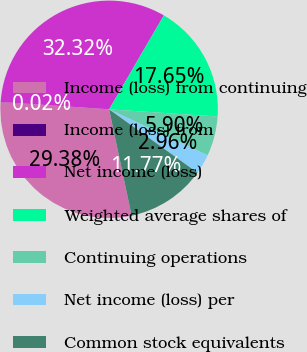<chart> <loc_0><loc_0><loc_500><loc_500><pie_chart><fcel>Income (loss) from continuing<fcel>Income (loss) from<fcel>Net income (loss)<fcel>Weighted average shares of<fcel>Continuing operations<fcel>Net income (loss) per<fcel>Common stock equivalents<nl><fcel>29.38%<fcel>0.02%<fcel>32.32%<fcel>17.65%<fcel>5.9%<fcel>2.96%<fcel>11.77%<nl></chart> 